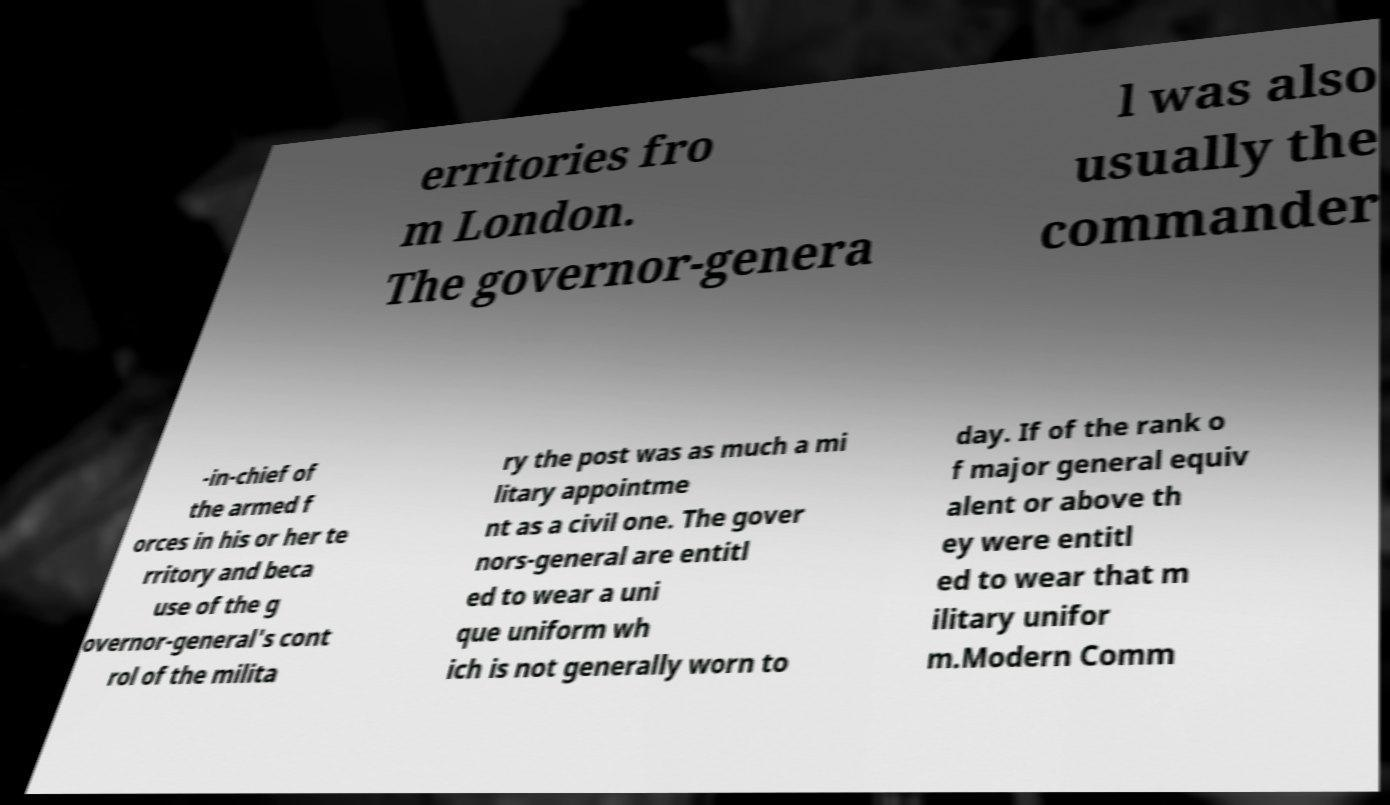Can you accurately transcribe the text from the provided image for me? erritories fro m London. The governor-genera l was also usually the commander -in-chief of the armed f orces in his or her te rritory and beca use of the g overnor-general's cont rol of the milita ry the post was as much a mi litary appointme nt as a civil one. The gover nors-general are entitl ed to wear a uni que uniform wh ich is not generally worn to day. If of the rank o f major general equiv alent or above th ey were entitl ed to wear that m ilitary unifor m.Modern Comm 